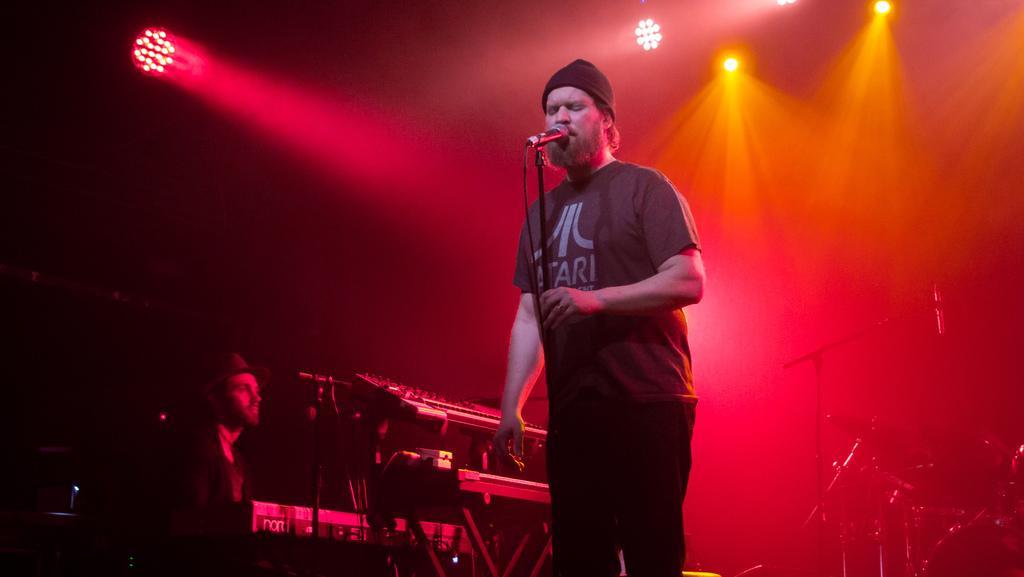How would you summarize this image in a sentence or two? There is a man singing on the mike. Here we can see a person and musical instruments. In the background there are lights. 